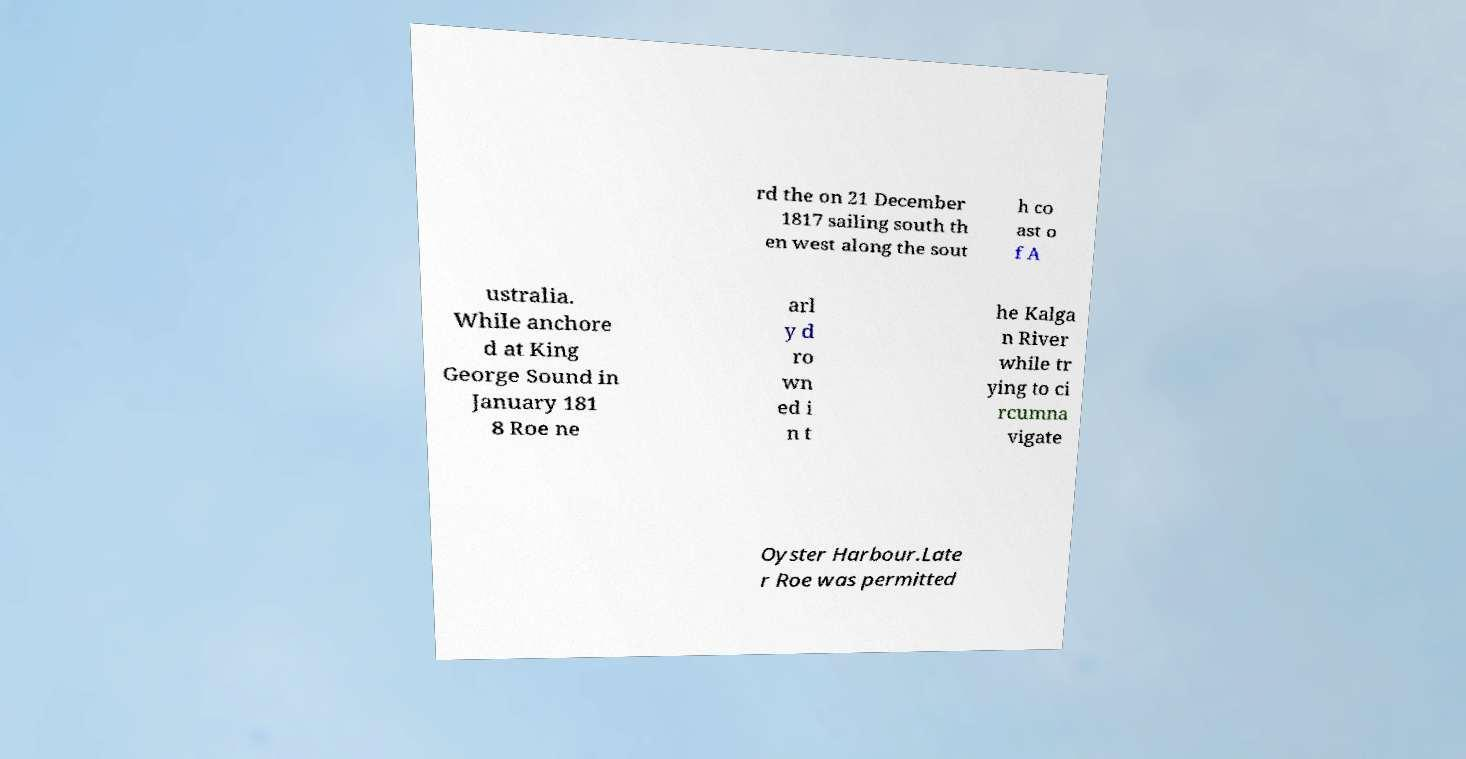What messages or text are displayed in this image? I need them in a readable, typed format. rd the on 21 December 1817 sailing south th en west along the sout h co ast o f A ustralia. While anchore d at King George Sound in January 181 8 Roe ne arl y d ro wn ed i n t he Kalga n River while tr ying to ci rcumna vigate Oyster Harbour.Late r Roe was permitted 